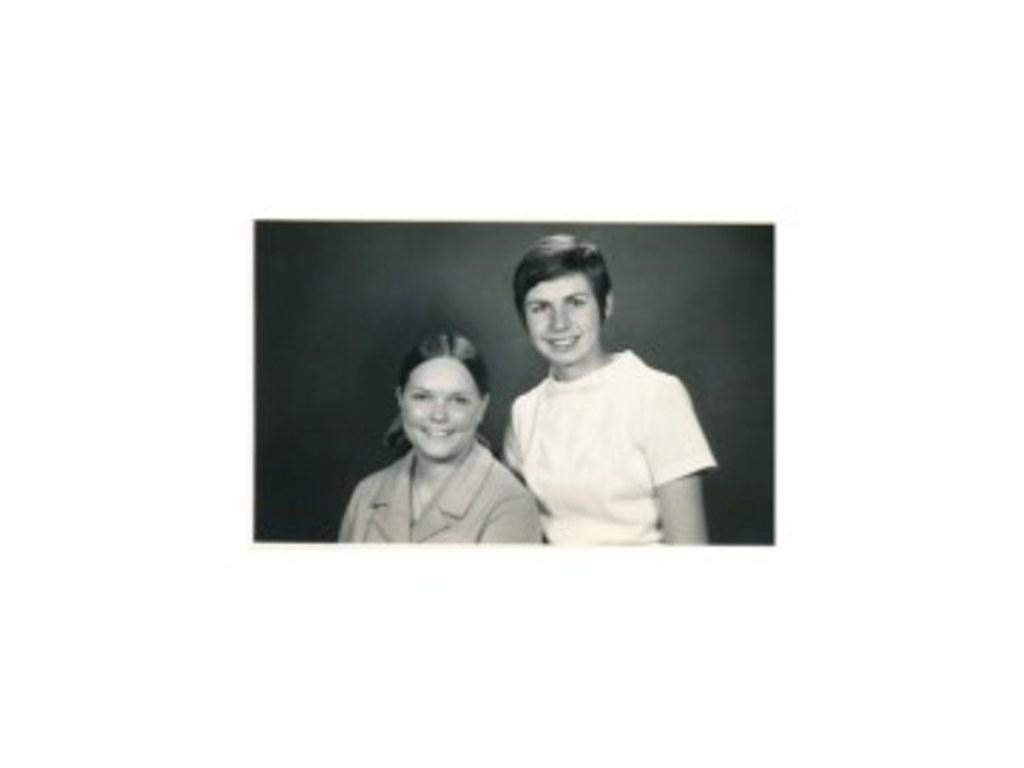What is the color scheme of the image? The image is black and white. How many people are in the image? There are two ladies in the image. What is the facial expression of the ladies in the image? Both ladies are smiling. What type of tin can be seen in the image? There is no tin present in the image. What agreement are the ladies discussing in the image? There is no indication of any discussion or agreement in the image; the ladies are simply smiling. 